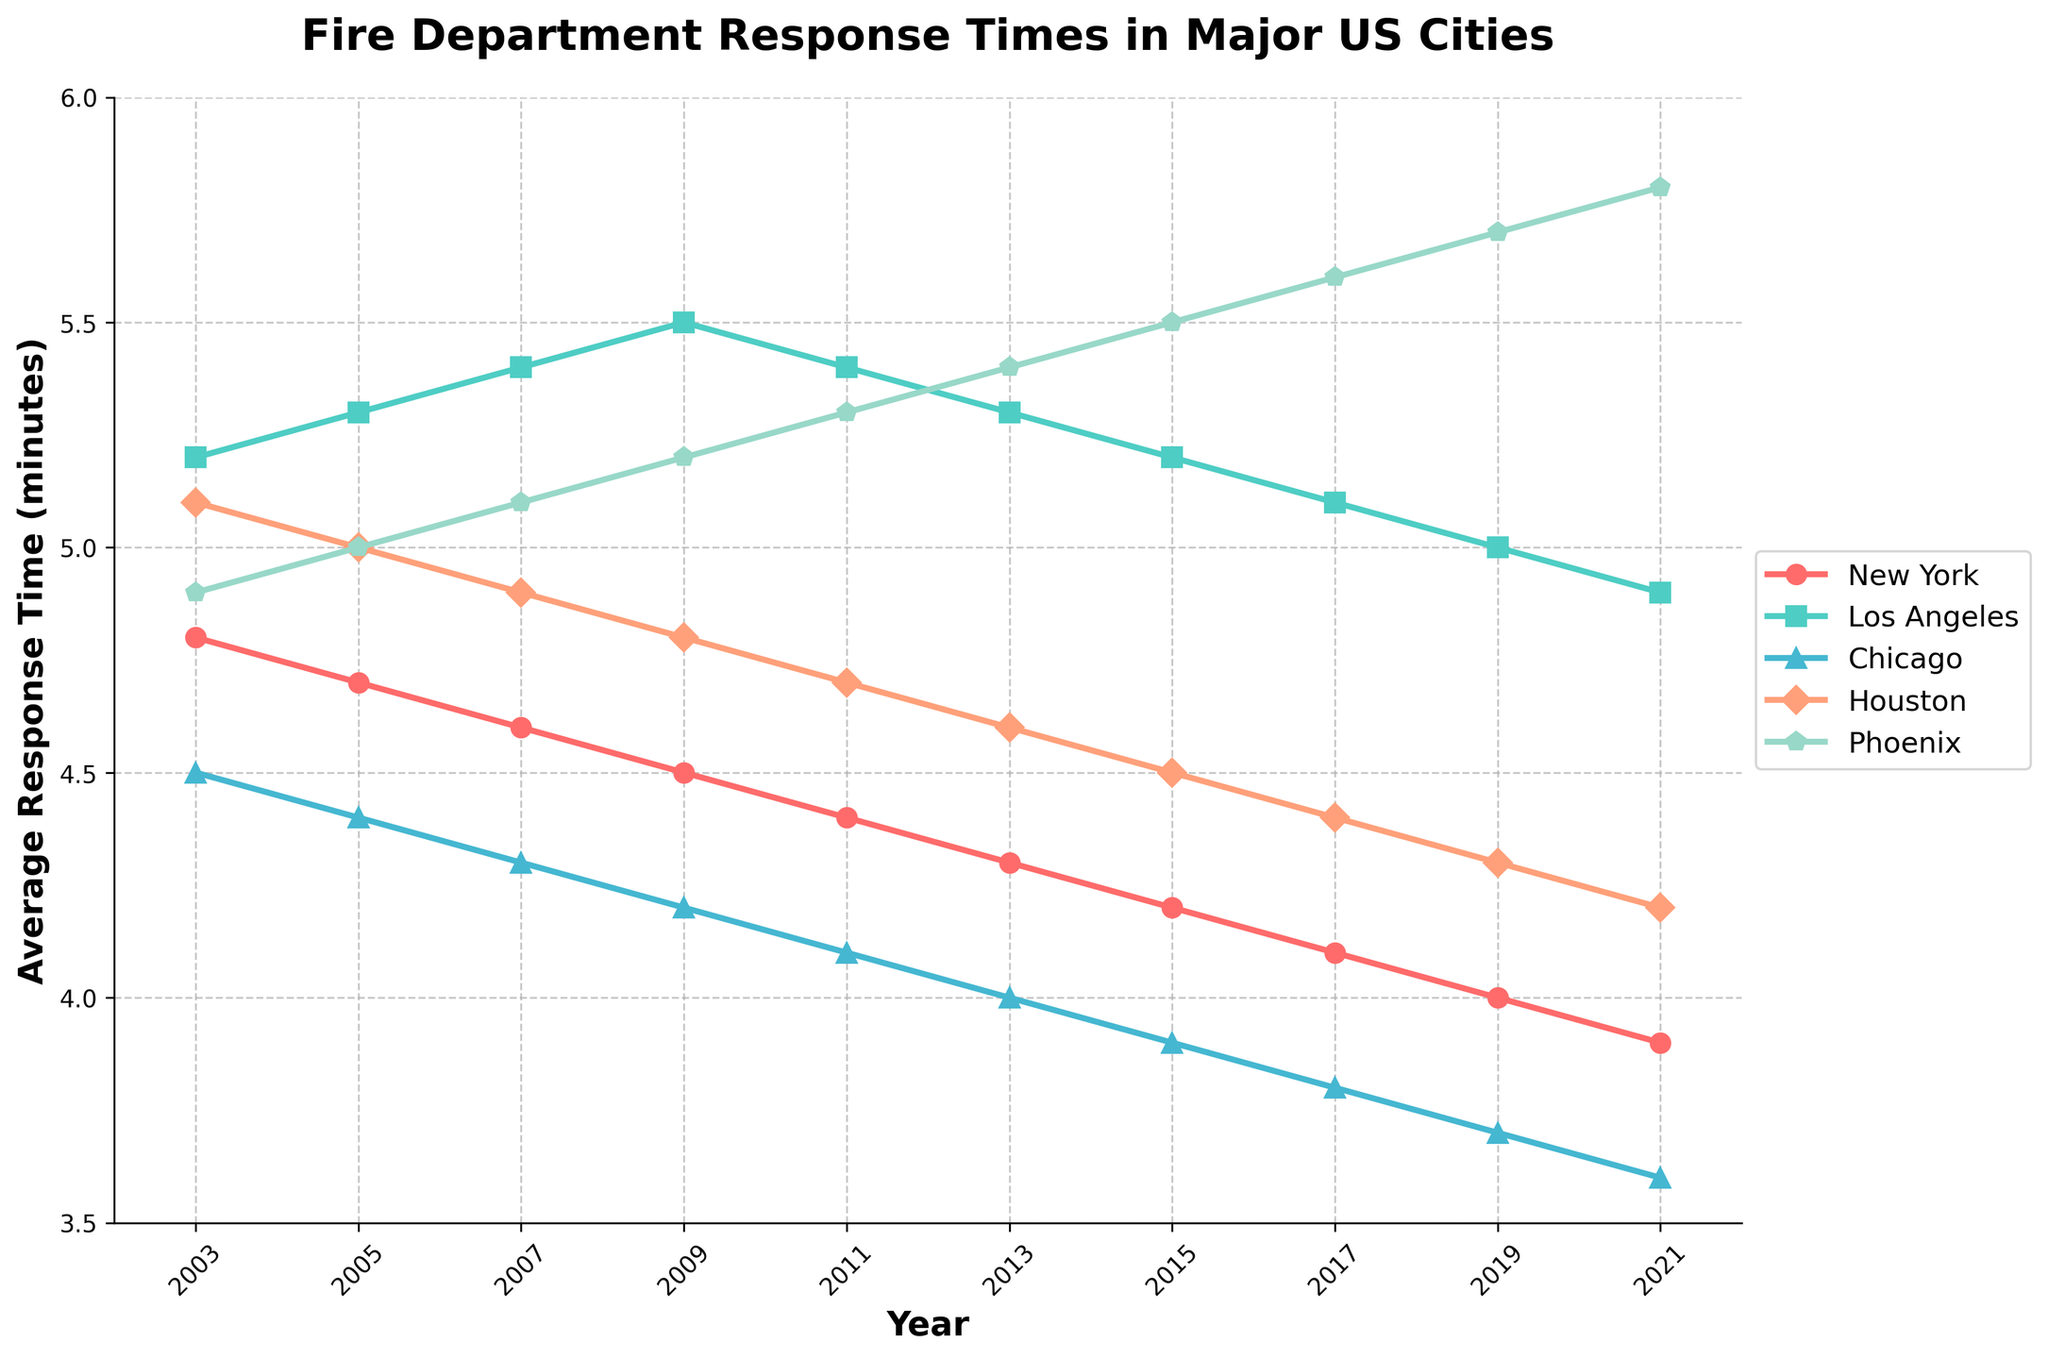Which city had the highest average response time in 2021? Look at the data points for the year 2021 and identify the city with the highest value. Phoenix has a 5.8-minute response time, which is the highest among all cities in that year.
Answer: Phoenix Between 2003 and 2021, how much did the average response time decrease in Chicago? Subtract the average response time in 2021 from the average response time in 2003 for Chicago. In 2003, the response time was 4.5 minutes, and in 2021 it was 3.6 minutes. The difference is 4.5 - 3.6 = 0.9 minutes.
Answer: 0.9 minutes Which city showed the most consistent decrease in response time over the years? Look at the trend lines of all cities and identify the one with a consistently downward slope. New York's line shows a steady decrease from 4.8 minutes in 2003 to 3.9 minutes in 2021.
Answer: New York By how many minutes did Houston's response time decrease between 2003 and 2017? Subtract Houston's response time in 2017 from its response time in 2003. In 2003, it was 5.1 minutes, and in 2017 it was 4.4 minutes. The difference is 5.1 - 4.4 = 0.7 minutes.
Answer: 0.7 minutes In which year did Los Angeles have its highest response time, and what was it? Identify the peak point of Los Angeles in the line chart. Los Angeles had its highest response time in 2009 at 5.5 minutes.
Answer: 2009, 5.5 minutes Compare the response times of New York and Phoenix in 2013. Which city had a faster response time? Look at the data points for both New York and Phoenix in 2013. New York had a response time of 4.3 minutes, while Phoenix had 5.4 minutes. New York had a faster response time.
Answer: New York What is the average response time for Chicago across the entire 20 years? Add up all the response times for Chicago and divide by the number of years (10). The sum is 4.5 + 4.4 + 4.3 + 4.2 + 4.1 + 4.0 + 3.9 + 3.8 + 3.7 + 3.6 = 40.5. The average is 40.5 / 10 = 4.05 minutes.
Answer: 4.05 minutes In what year did Phoenix first surpass a 5-minute average response time? Look at the trend for Phoenix and find the first year in which the response time is greater than 5 minutes. This occurs in 2005, with a response time of 5.0 minutes.
Answer: 2005 How much higher was the response time in Los Angeles compared to New York in 2011? Find the response times for Los Angeles and New York in 2011. Los Angeles had 5.4 minutes and New York had 4.4 minutes. The difference is 5.4 - 4.4 = 1 minute.
Answer: 1 minute What was the trend in Houston's response time between 2007 and 2011? Look at the data points for Houston between the years 2007 and 2011. In 2007, it was 4.9 minutes and by 2011 it decreased to 4.7 minutes. This indicates a trend of decreasing response time.
Answer: Decreasing 